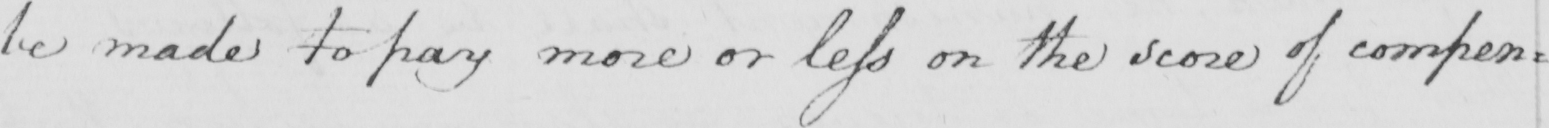What is written in this line of handwriting? be made to pay more or less on the score of compen= 